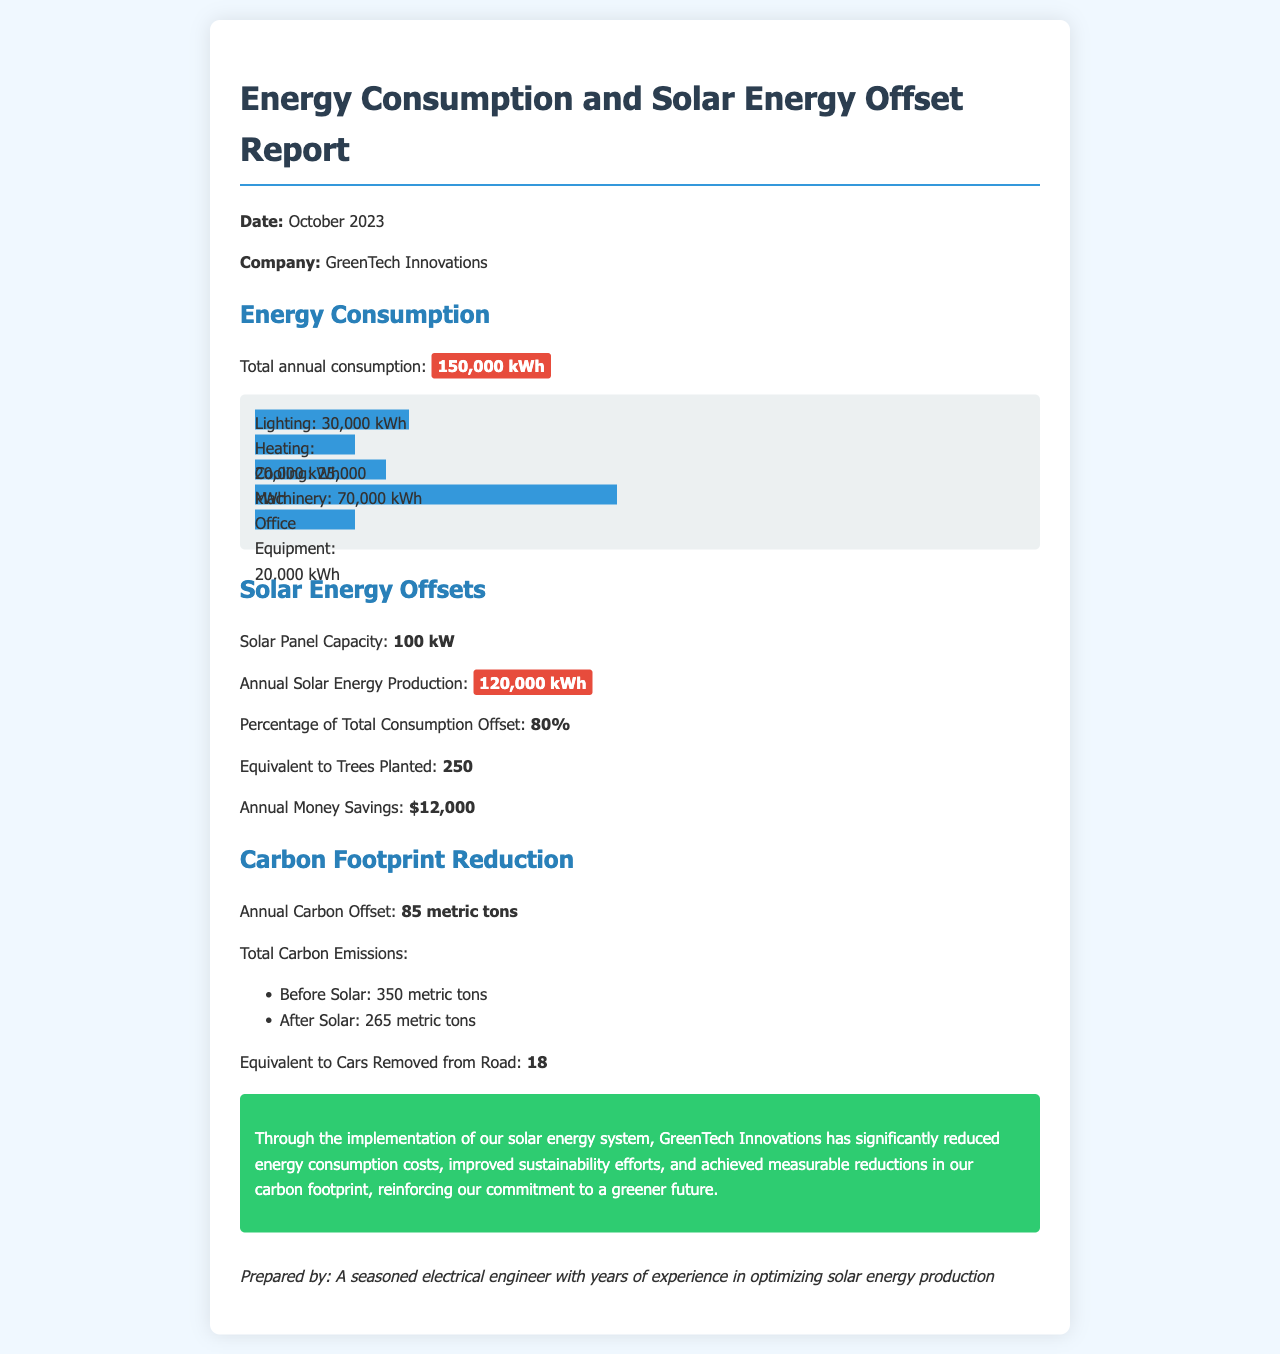What is the total annual consumption? The total annual consumption is specified as 150,000 kWh in the report.
Answer: 150,000 kWh What is the solar panel capacity? The report states that the solar panel capacity is 100 kW.
Answer: 100 kW How much annual solar energy is produced? The annual solar energy production is highlighted as 120,000 kWh.
Answer: 120,000 kWh What percentage of total consumption is offset by solar energy? The report states that 80% of total consumption is offset by solar energy.
Answer: 80% How many metric tons of carbon did the company offset annually? The annual carbon offset mentioned in the report is 85 metric tons.
Answer: 85 metric tons What is the equivalent number of cars removed from the road due to the carbon footprint reduction? The document states that this is equivalent to 18 cars removed from the road.
Answer: 18 What are the total carbon emissions before implementing solar energy? The total carbon emissions before solar implementation is listed as 350 metric tons.
Answer: 350 metric tons What is the annual money savings from the solar energy implementation? The report claims an annual money savings of $12,000 due to the solar energy system.
Answer: $12,000 What was the total carbon emissions after the implementation of solar energy? The total carbon emissions after implementing solar energy is noted as 265 metric tons.
Answer: 265 metric tons 